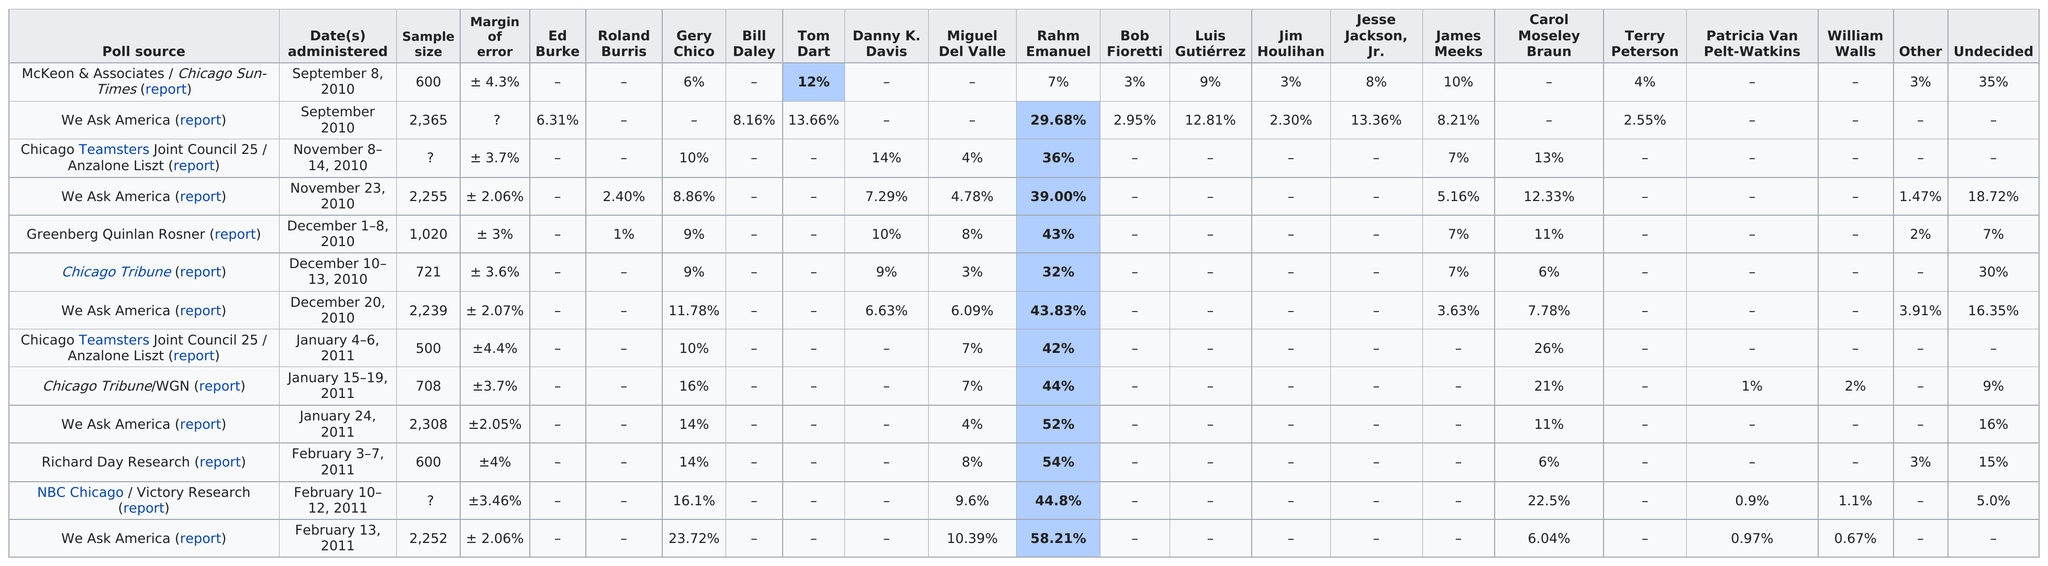Specify some key components in this picture. The average percentile among those who are voting for Rahm Emanuel in Chicago is 32%. Rahm Emanuel is the first candidate to achieve over 25% support. On February 13, 2011, Gery Chico had at least 23%. There are 17 candidates listed. The poll source with the largest sample size is We Ask America. 